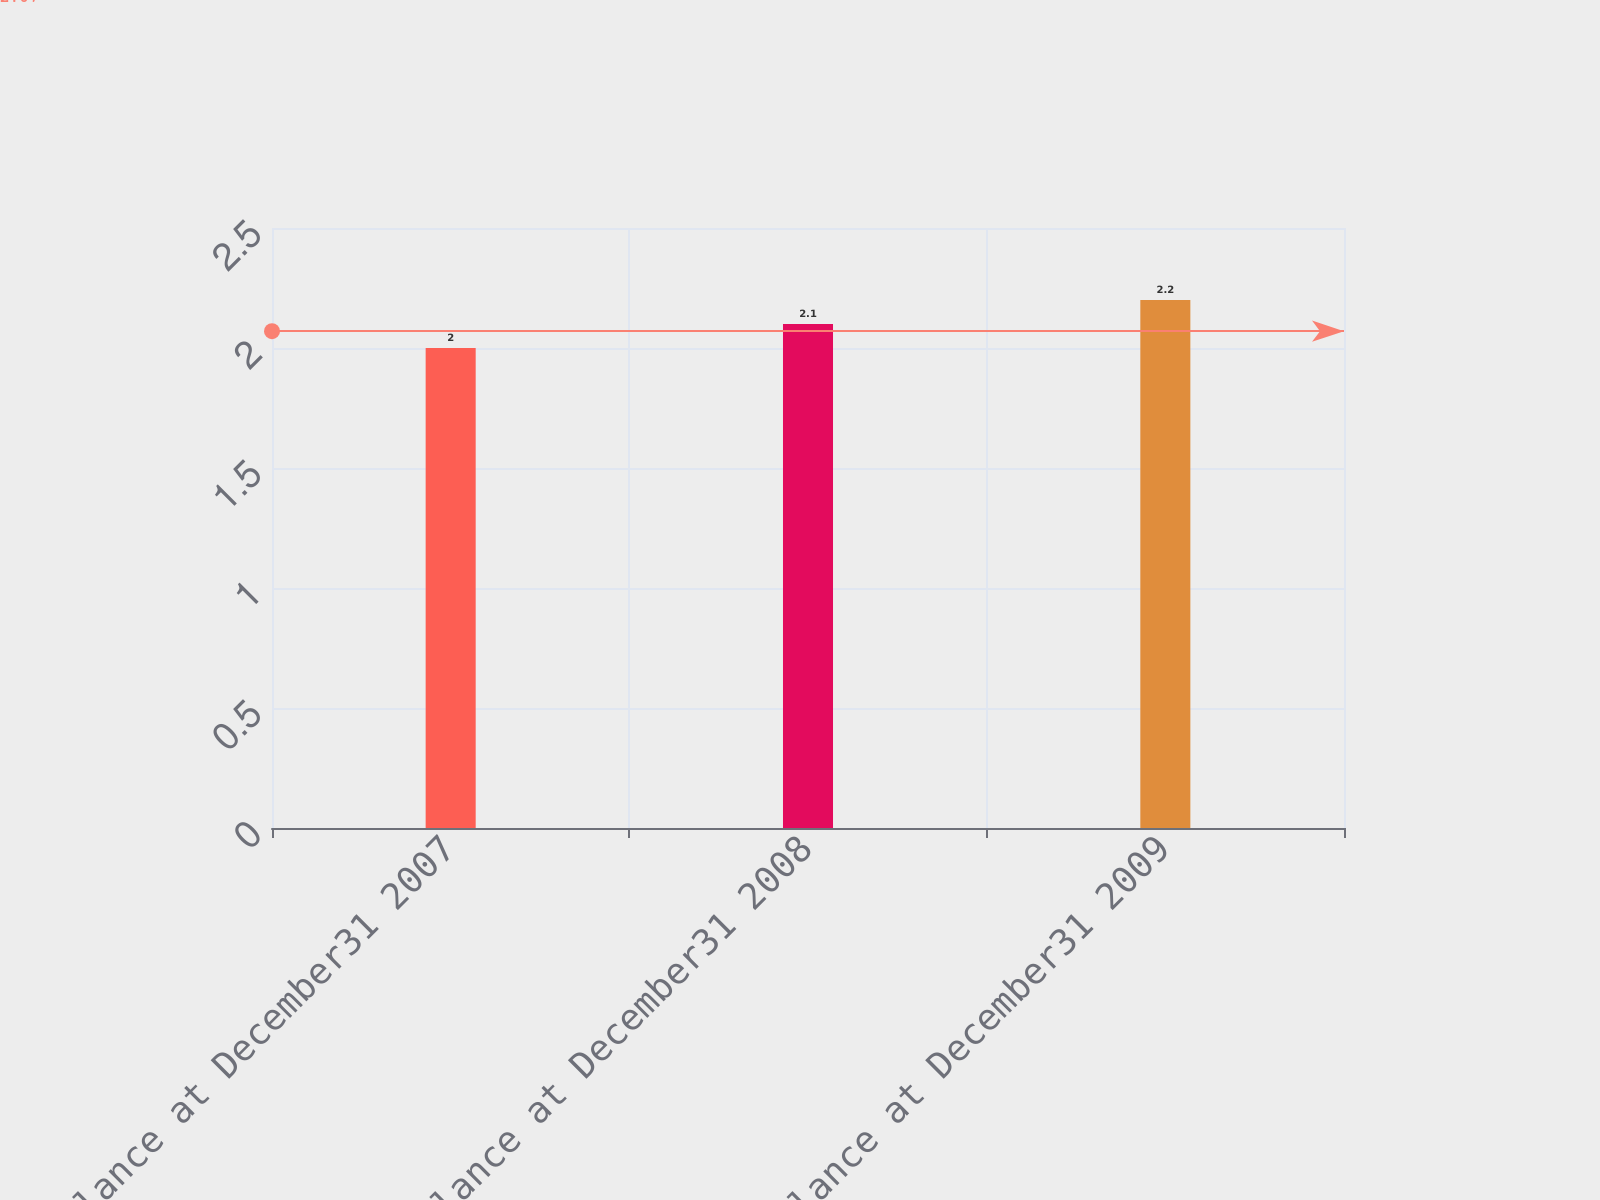<chart> <loc_0><loc_0><loc_500><loc_500><bar_chart><fcel>Balance at December31 2007<fcel>Balance at December31 2008<fcel>Balance at December31 2009<nl><fcel>2<fcel>2.1<fcel>2.2<nl></chart> 